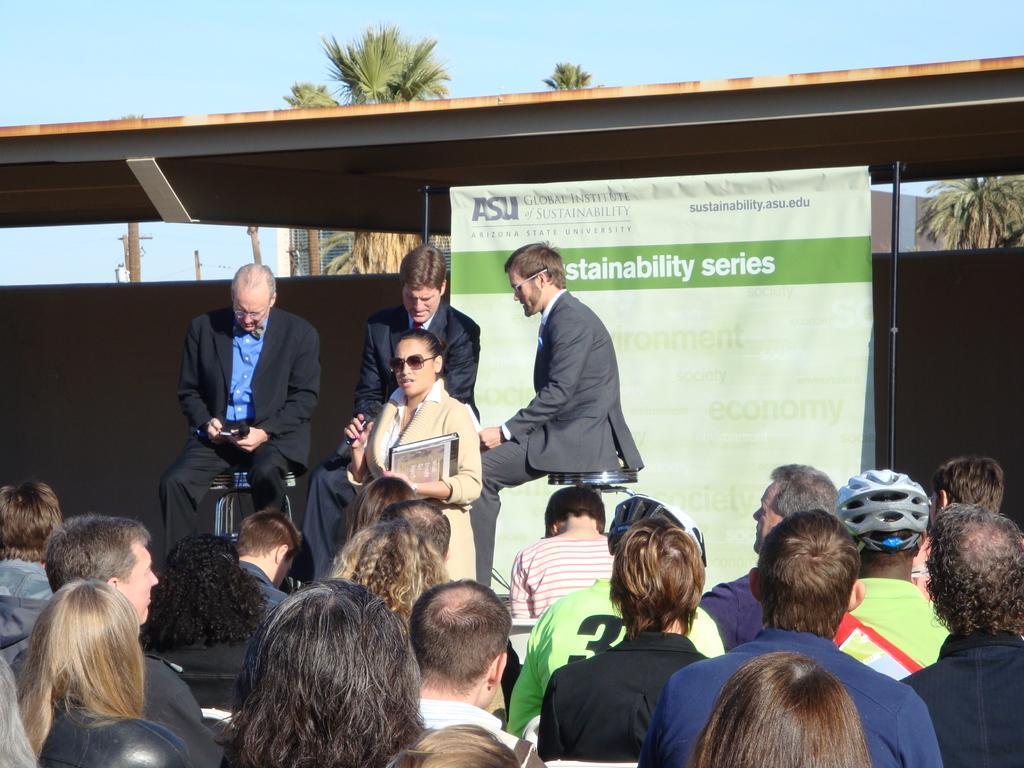Could you give a brief overview of what you see in this image? In this picture there are group of people sitting. There is a woman standing and holding the microphone and book and there are three persons sitting. At the back there is a banner and there is a text on the banner and there is a building and there are trees. At the top there is sky. 